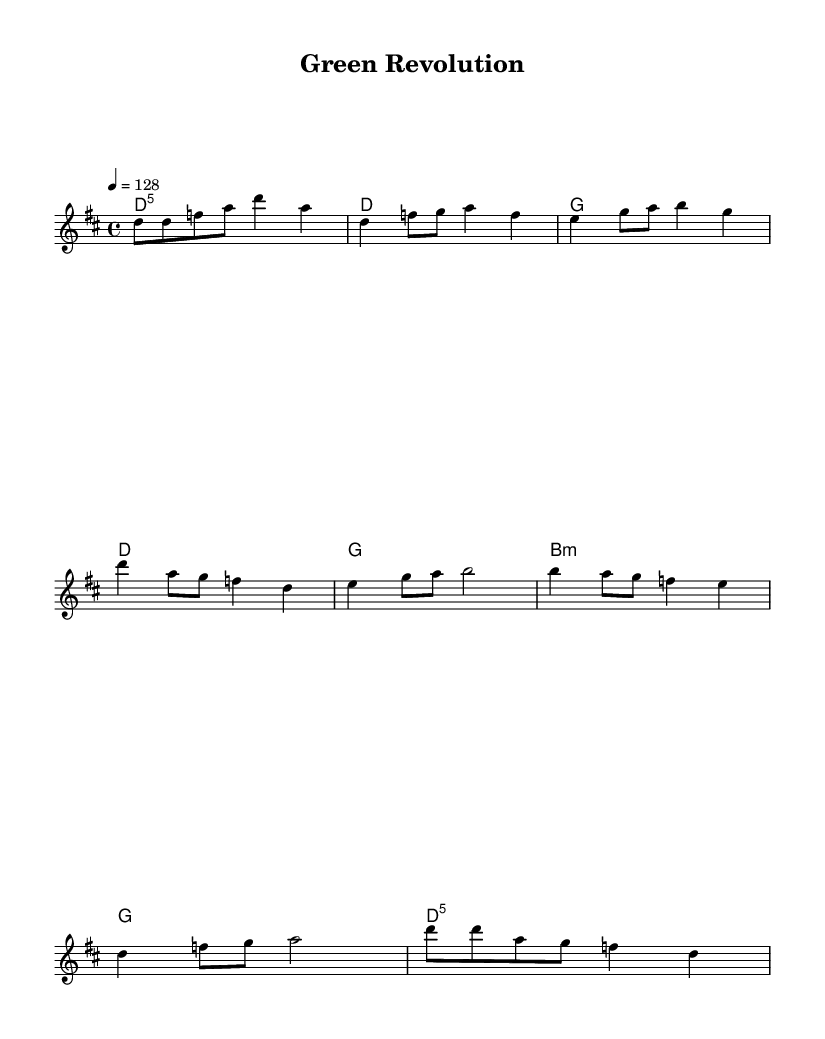What is the key signature of this music? The key signature is D major, which has two sharps (F# and C#). This is indicated at the beginning of the staff where the key signature is displayed.
Answer: D major What is the time signature of this music? The time signature is 4/4, meaning there are four beats in each measure and the quarter note gets one beat. This can be seen at the beginning of the staff where the time signature is shown.
Answer: 4/4 What is the tempo marking of this piece? The tempo marking is 128 beats per minute, indicated above the staff by the notation "4 = 128", which tells you the speed of the piece.
Answer: 128 How many measures are there in the chorus? The chorus consists of 4 measures, which can be counted visually on the score by identifying the sections marked with the lyrics corresponding to the chorus.
Answer: 4 What chord is played during the bridge? The chord played during the bridge is B minor, indicated by "b1:m" in the chord section of the music.
Answer: B minor What is the lyrical theme in the verse? The lyrical theme addresses environmental issues like toxic fumes and rising seas, as represented in the text of the verse lyrics indicating a sense of urgency about ecological responsibility.
Answer: Environmental issues What section follows the chorus? The section following the chorus is the bridge, which connects different parts of the song and is characterized by its distinct lyrics and harmonic progression.
Answer: Bridge 